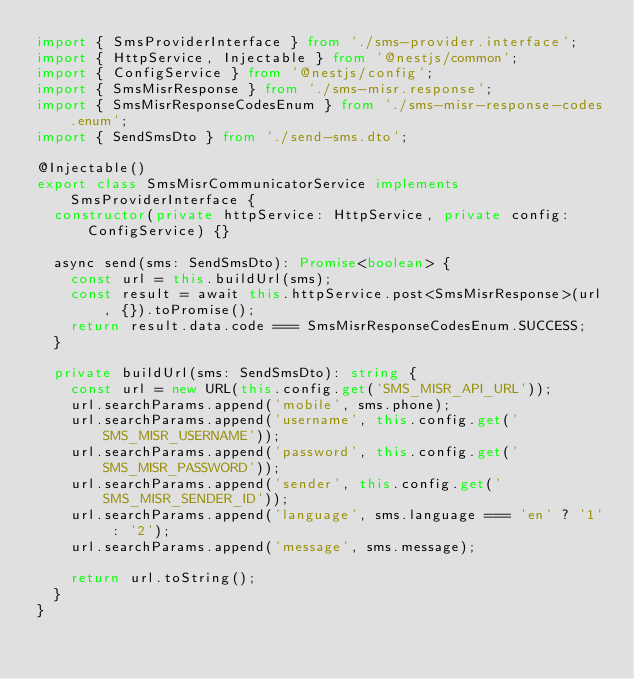Convert code to text. <code><loc_0><loc_0><loc_500><loc_500><_TypeScript_>import { SmsProviderInterface } from './sms-provider.interface';
import { HttpService, Injectable } from '@nestjs/common';
import { ConfigService } from '@nestjs/config';
import { SmsMisrResponse } from './sms-misr.response';
import { SmsMisrResponseCodesEnum } from './sms-misr-response-codes.enum';
import { SendSmsDto } from './send-sms.dto';

@Injectable()
export class SmsMisrCommunicatorService implements SmsProviderInterface {
  constructor(private httpService: HttpService, private config: ConfigService) {}

  async send(sms: SendSmsDto): Promise<boolean> {
    const url = this.buildUrl(sms);
    const result = await this.httpService.post<SmsMisrResponse>(url, {}).toPromise();
    return result.data.code === SmsMisrResponseCodesEnum.SUCCESS;
  }

  private buildUrl(sms: SendSmsDto): string {
    const url = new URL(this.config.get('SMS_MISR_API_URL'));
    url.searchParams.append('mobile', sms.phone);
    url.searchParams.append('username', this.config.get('SMS_MISR_USERNAME'));
    url.searchParams.append('password', this.config.get('SMS_MISR_PASSWORD'));
    url.searchParams.append('sender', this.config.get('SMS_MISR_SENDER_ID'));
    url.searchParams.append('language', sms.language === 'en' ? '1' : '2');
    url.searchParams.append('message', sms.message);

    return url.toString();
  }
}
</code> 